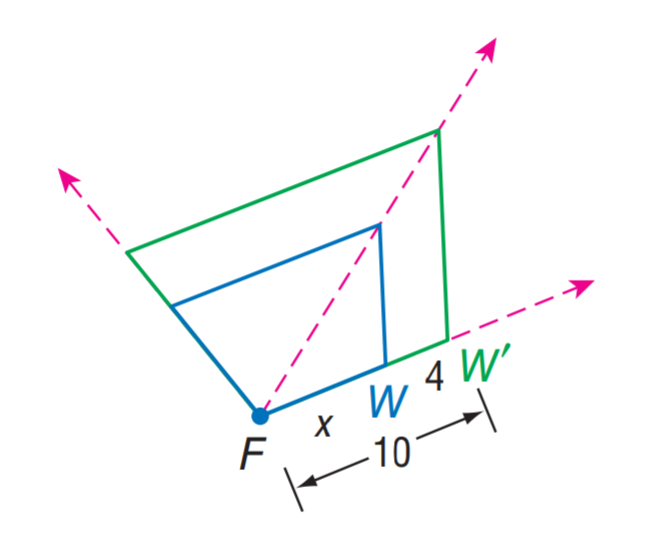Answer the mathemtical geometry problem and directly provide the correct option letter.
Question: Find the scale factor from W to W'.
Choices: A: 0.4 B: 0.6 C: 0.8 D: 1 B 